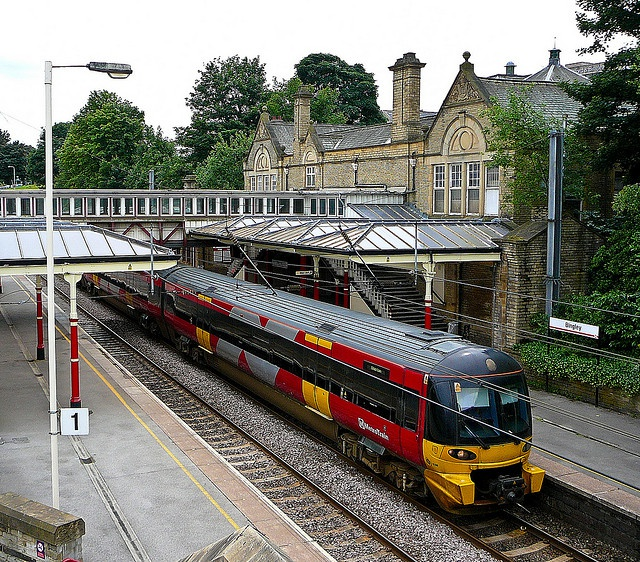Describe the objects in this image and their specific colors. I can see a train in white, black, gray, maroon, and darkgray tones in this image. 